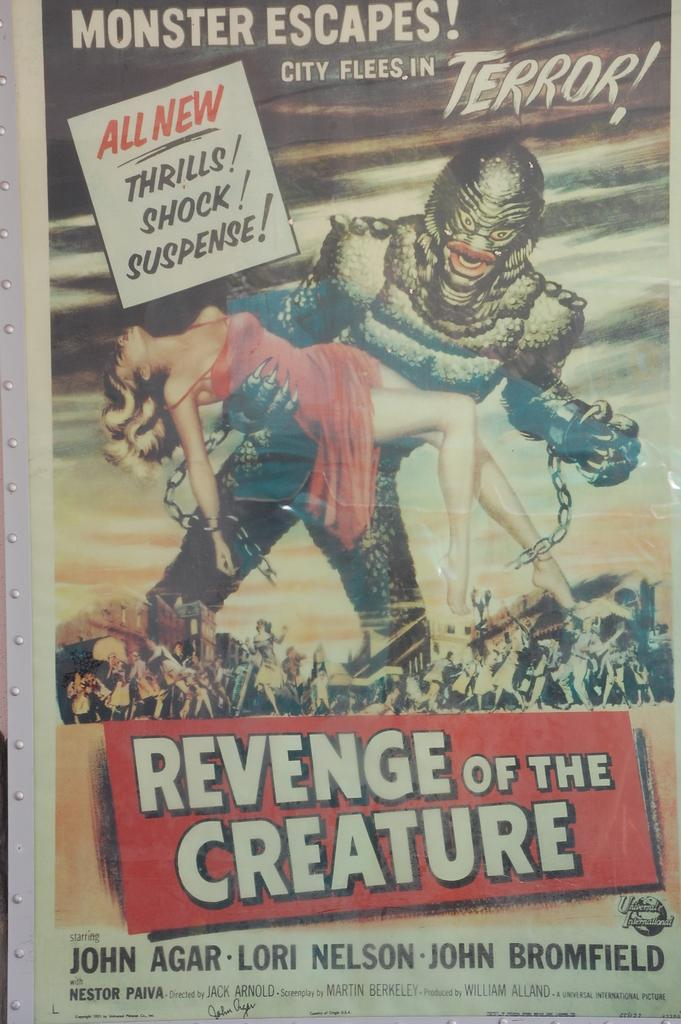<image>
Present a compact description of the photo's key features. Vintage movie poster for Revenge of the Creature with John Agar, Lori Nelson and John Bromfield. 